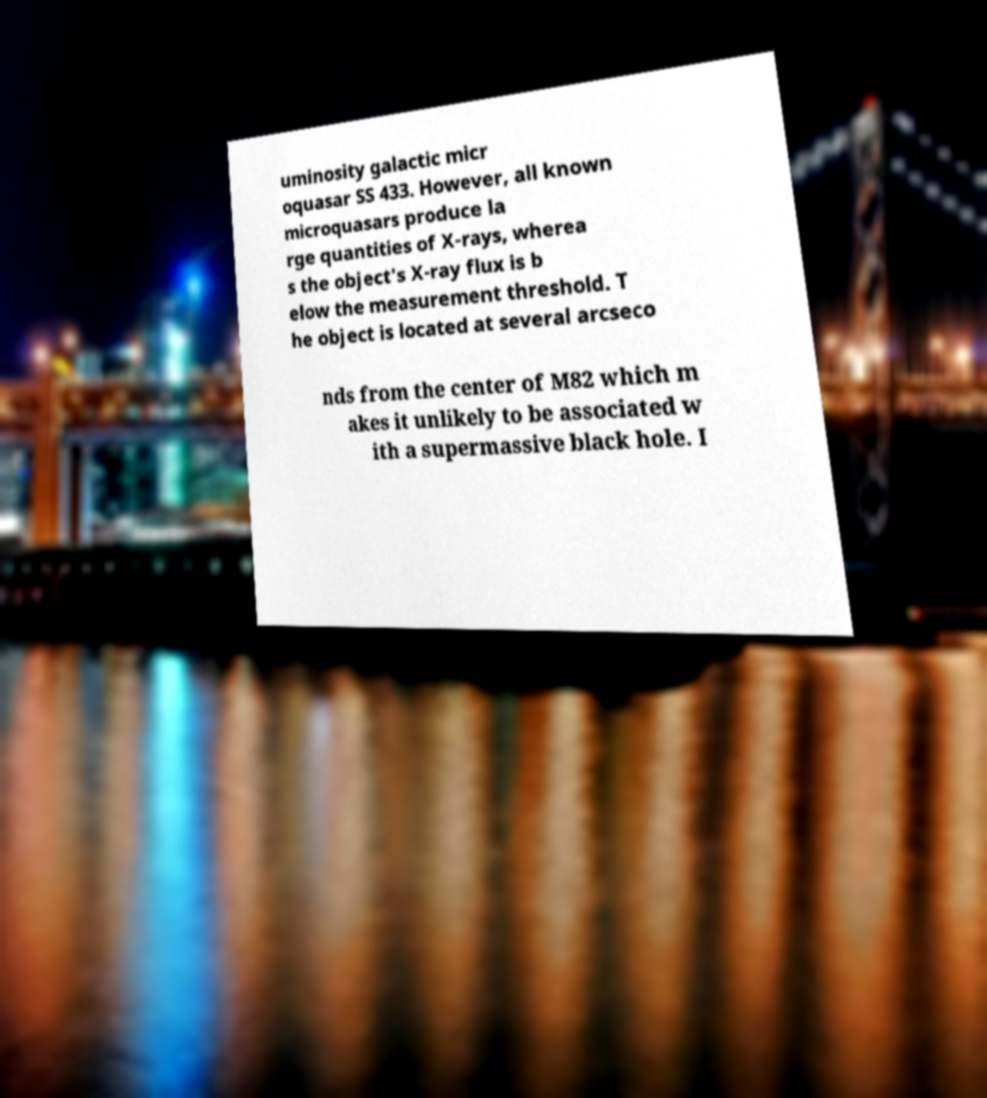Could you assist in decoding the text presented in this image and type it out clearly? uminosity galactic micr oquasar SS 433. However, all known microquasars produce la rge quantities of X-rays, wherea s the object's X-ray flux is b elow the measurement threshold. T he object is located at several arcseco nds from the center of M82 which m akes it unlikely to be associated w ith a supermassive black hole. I 